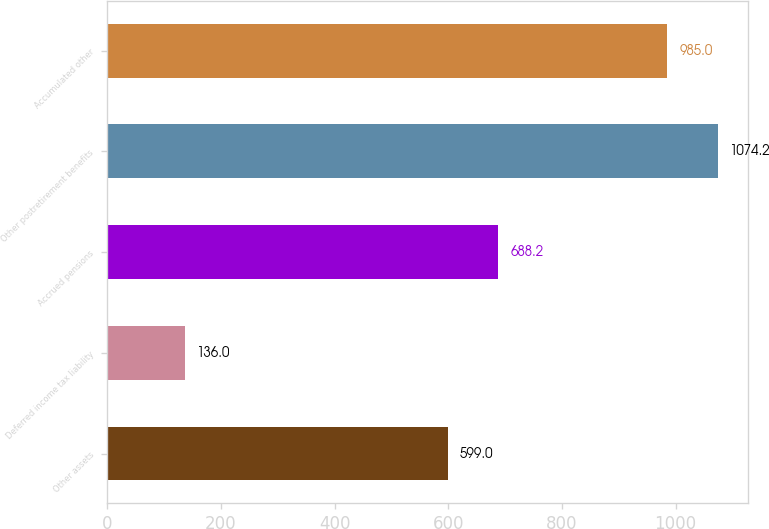Convert chart. <chart><loc_0><loc_0><loc_500><loc_500><bar_chart><fcel>Other assets<fcel>Deferred income tax liability<fcel>Accrued pensions<fcel>Other postretirement benefits<fcel>Accumulated other<nl><fcel>599<fcel>136<fcel>688.2<fcel>1074.2<fcel>985<nl></chart> 